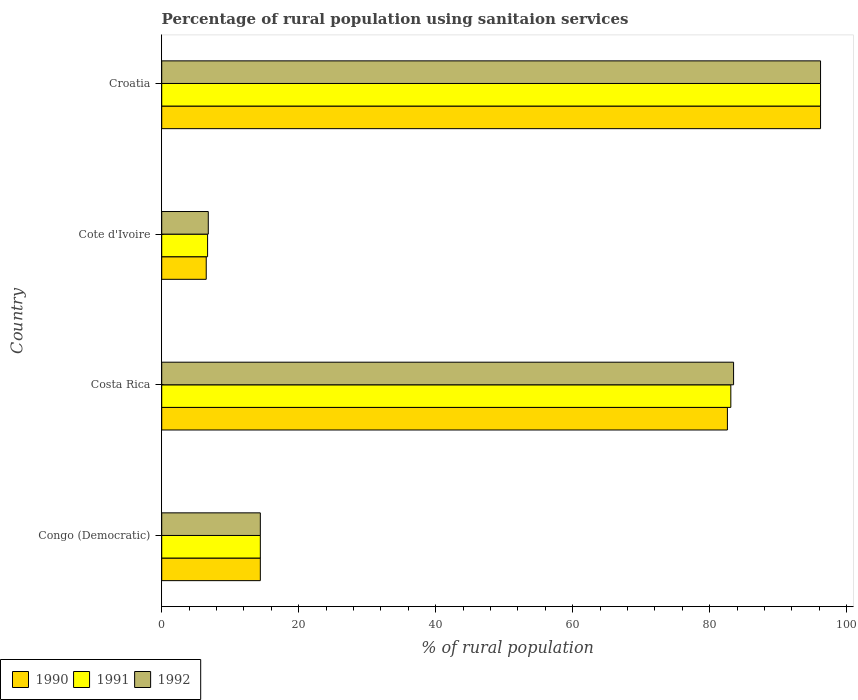Are the number of bars per tick equal to the number of legend labels?
Provide a succinct answer. Yes. How many bars are there on the 1st tick from the top?
Offer a very short reply. 3. In how many cases, is the number of bars for a given country not equal to the number of legend labels?
Provide a short and direct response. 0. What is the percentage of rural population using sanitaion services in 1992 in Congo (Democratic)?
Your answer should be compact. 14.4. Across all countries, what is the maximum percentage of rural population using sanitaion services in 1991?
Offer a terse response. 96.2. Across all countries, what is the minimum percentage of rural population using sanitaion services in 1991?
Offer a terse response. 6.7. In which country was the percentage of rural population using sanitaion services in 1991 maximum?
Your answer should be compact. Croatia. In which country was the percentage of rural population using sanitaion services in 1990 minimum?
Offer a very short reply. Cote d'Ivoire. What is the total percentage of rural population using sanitaion services in 1992 in the graph?
Your answer should be very brief. 200.9. What is the difference between the percentage of rural population using sanitaion services in 1990 in Costa Rica and that in Croatia?
Make the answer very short. -13.6. What is the difference between the percentage of rural population using sanitaion services in 1991 in Croatia and the percentage of rural population using sanitaion services in 1990 in Congo (Democratic)?
Make the answer very short. 81.8. What is the average percentage of rural population using sanitaion services in 1990 per country?
Ensure brevity in your answer.  49.92. What is the difference between the percentage of rural population using sanitaion services in 1990 and percentage of rural population using sanitaion services in 1992 in Congo (Democratic)?
Ensure brevity in your answer.  0. What is the ratio of the percentage of rural population using sanitaion services in 1991 in Congo (Democratic) to that in Croatia?
Your response must be concise. 0.15. What is the difference between the highest and the second highest percentage of rural population using sanitaion services in 1991?
Your answer should be very brief. 13.1. What is the difference between the highest and the lowest percentage of rural population using sanitaion services in 1992?
Your answer should be very brief. 89.4. In how many countries, is the percentage of rural population using sanitaion services in 1991 greater than the average percentage of rural population using sanitaion services in 1991 taken over all countries?
Provide a short and direct response. 2. Is the sum of the percentage of rural population using sanitaion services in 1990 in Congo (Democratic) and Cote d'Ivoire greater than the maximum percentage of rural population using sanitaion services in 1992 across all countries?
Offer a terse response. No. What does the 3rd bar from the bottom in Cote d'Ivoire represents?
Provide a short and direct response. 1992. How many bars are there?
Provide a succinct answer. 12. What is the difference between two consecutive major ticks on the X-axis?
Ensure brevity in your answer.  20. Where does the legend appear in the graph?
Your answer should be compact. Bottom left. How are the legend labels stacked?
Offer a very short reply. Horizontal. What is the title of the graph?
Keep it short and to the point. Percentage of rural population using sanitaion services. Does "2010" appear as one of the legend labels in the graph?
Your answer should be very brief. No. What is the label or title of the X-axis?
Your response must be concise. % of rural population. What is the % of rural population in 1991 in Congo (Democratic)?
Keep it short and to the point. 14.4. What is the % of rural population of 1990 in Costa Rica?
Make the answer very short. 82.6. What is the % of rural population of 1991 in Costa Rica?
Ensure brevity in your answer.  83.1. What is the % of rural population in 1992 in Costa Rica?
Make the answer very short. 83.5. What is the % of rural population in 1992 in Cote d'Ivoire?
Offer a terse response. 6.8. What is the % of rural population of 1990 in Croatia?
Offer a terse response. 96.2. What is the % of rural population of 1991 in Croatia?
Ensure brevity in your answer.  96.2. What is the % of rural population of 1992 in Croatia?
Offer a very short reply. 96.2. Across all countries, what is the maximum % of rural population in 1990?
Offer a very short reply. 96.2. Across all countries, what is the maximum % of rural population in 1991?
Provide a short and direct response. 96.2. Across all countries, what is the maximum % of rural population of 1992?
Ensure brevity in your answer.  96.2. Across all countries, what is the minimum % of rural population of 1992?
Provide a succinct answer. 6.8. What is the total % of rural population of 1990 in the graph?
Provide a short and direct response. 199.7. What is the total % of rural population in 1991 in the graph?
Ensure brevity in your answer.  200.4. What is the total % of rural population of 1992 in the graph?
Your answer should be compact. 200.9. What is the difference between the % of rural population in 1990 in Congo (Democratic) and that in Costa Rica?
Your answer should be very brief. -68.2. What is the difference between the % of rural population in 1991 in Congo (Democratic) and that in Costa Rica?
Your answer should be compact. -68.7. What is the difference between the % of rural population of 1992 in Congo (Democratic) and that in Costa Rica?
Offer a terse response. -69.1. What is the difference between the % of rural population in 1992 in Congo (Democratic) and that in Cote d'Ivoire?
Keep it short and to the point. 7.6. What is the difference between the % of rural population of 1990 in Congo (Democratic) and that in Croatia?
Your answer should be compact. -81.8. What is the difference between the % of rural population of 1991 in Congo (Democratic) and that in Croatia?
Your response must be concise. -81.8. What is the difference between the % of rural population in 1992 in Congo (Democratic) and that in Croatia?
Make the answer very short. -81.8. What is the difference between the % of rural population in 1990 in Costa Rica and that in Cote d'Ivoire?
Provide a succinct answer. 76.1. What is the difference between the % of rural population in 1991 in Costa Rica and that in Cote d'Ivoire?
Ensure brevity in your answer.  76.4. What is the difference between the % of rural population of 1992 in Costa Rica and that in Cote d'Ivoire?
Provide a short and direct response. 76.7. What is the difference between the % of rural population in 1990 in Costa Rica and that in Croatia?
Your answer should be very brief. -13.6. What is the difference between the % of rural population of 1991 in Costa Rica and that in Croatia?
Your response must be concise. -13.1. What is the difference between the % of rural population of 1992 in Costa Rica and that in Croatia?
Your answer should be compact. -12.7. What is the difference between the % of rural population of 1990 in Cote d'Ivoire and that in Croatia?
Ensure brevity in your answer.  -89.7. What is the difference between the % of rural population of 1991 in Cote d'Ivoire and that in Croatia?
Give a very brief answer. -89.5. What is the difference between the % of rural population of 1992 in Cote d'Ivoire and that in Croatia?
Your answer should be compact. -89.4. What is the difference between the % of rural population of 1990 in Congo (Democratic) and the % of rural population of 1991 in Costa Rica?
Make the answer very short. -68.7. What is the difference between the % of rural population in 1990 in Congo (Democratic) and the % of rural population in 1992 in Costa Rica?
Ensure brevity in your answer.  -69.1. What is the difference between the % of rural population in 1991 in Congo (Democratic) and the % of rural population in 1992 in Costa Rica?
Your response must be concise. -69.1. What is the difference between the % of rural population in 1990 in Congo (Democratic) and the % of rural population in 1991 in Croatia?
Your answer should be compact. -81.8. What is the difference between the % of rural population of 1990 in Congo (Democratic) and the % of rural population of 1992 in Croatia?
Ensure brevity in your answer.  -81.8. What is the difference between the % of rural population of 1991 in Congo (Democratic) and the % of rural population of 1992 in Croatia?
Keep it short and to the point. -81.8. What is the difference between the % of rural population in 1990 in Costa Rica and the % of rural population in 1991 in Cote d'Ivoire?
Make the answer very short. 75.9. What is the difference between the % of rural population of 1990 in Costa Rica and the % of rural population of 1992 in Cote d'Ivoire?
Provide a succinct answer. 75.8. What is the difference between the % of rural population of 1991 in Costa Rica and the % of rural population of 1992 in Cote d'Ivoire?
Provide a short and direct response. 76.3. What is the difference between the % of rural population in 1990 in Costa Rica and the % of rural population in 1992 in Croatia?
Offer a terse response. -13.6. What is the difference between the % of rural population in 1991 in Costa Rica and the % of rural population in 1992 in Croatia?
Provide a succinct answer. -13.1. What is the difference between the % of rural population of 1990 in Cote d'Ivoire and the % of rural population of 1991 in Croatia?
Keep it short and to the point. -89.7. What is the difference between the % of rural population in 1990 in Cote d'Ivoire and the % of rural population in 1992 in Croatia?
Ensure brevity in your answer.  -89.7. What is the difference between the % of rural population of 1991 in Cote d'Ivoire and the % of rural population of 1992 in Croatia?
Your answer should be compact. -89.5. What is the average % of rural population in 1990 per country?
Ensure brevity in your answer.  49.92. What is the average % of rural population of 1991 per country?
Offer a very short reply. 50.1. What is the average % of rural population in 1992 per country?
Make the answer very short. 50.23. What is the difference between the % of rural population in 1991 and % of rural population in 1992 in Congo (Democratic)?
Offer a terse response. 0. What is the difference between the % of rural population of 1991 and % of rural population of 1992 in Costa Rica?
Offer a very short reply. -0.4. What is the difference between the % of rural population of 1990 and % of rural population of 1992 in Cote d'Ivoire?
Provide a succinct answer. -0.3. What is the difference between the % of rural population in 1991 and % of rural population in 1992 in Cote d'Ivoire?
Offer a terse response. -0.1. What is the difference between the % of rural population in 1990 and % of rural population in 1991 in Croatia?
Provide a succinct answer. 0. What is the difference between the % of rural population in 1990 and % of rural population in 1992 in Croatia?
Provide a succinct answer. 0. What is the ratio of the % of rural population in 1990 in Congo (Democratic) to that in Costa Rica?
Make the answer very short. 0.17. What is the ratio of the % of rural population of 1991 in Congo (Democratic) to that in Costa Rica?
Offer a terse response. 0.17. What is the ratio of the % of rural population of 1992 in Congo (Democratic) to that in Costa Rica?
Make the answer very short. 0.17. What is the ratio of the % of rural population in 1990 in Congo (Democratic) to that in Cote d'Ivoire?
Provide a succinct answer. 2.22. What is the ratio of the % of rural population in 1991 in Congo (Democratic) to that in Cote d'Ivoire?
Keep it short and to the point. 2.15. What is the ratio of the % of rural population of 1992 in Congo (Democratic) to that in Cote d'Ivoire?
Ensure brevity in your answer.  2.12. What is the ratio of the % of rural population in 1990 in Congo (Democratic) to that in Croatia?
Provide a succinct answer. 0.15. What is the ratio of the % of rural population in 1991 in Congo (Democratic) to that in Croatia?
Your answer should be compact. 0.15. What is the ratio of the % of rural population of 1992 in Congo (Democratic) to that in Croatia?
Your answer should be compact. 0.15. What is the ratio of the % of rural population of 1990 in Costa Rica to that in Cote d'Ivoire?
Offer a very short reply. 12.71. What is the ratio of the % of rural population in 1991 in Costa Rica to that in Cote d'Ivoire?
Your answer should be very brief. 12.4. What is the ratio of the % of rural population in 1992 in Costa Rica to that in Cote d'Ivoire?
Make the answer very short. 12.28. What is the ratio of the % of rural population of 1990 in Costa Rica to that in Croatia?
Your response must be concise. 0.86. What is the ratio of the % of rural population of 1991 in Costa Rica to that in Croatia?
Make the answer very short. 0.86. What is the ratio of the % of rural population in 1992 in Costa Rica to that in Croatia?
Provide a short and direct response. 0.87. What is the ratio of the % of rural population of 1990 in Cote d'Ivoire to that in Croatia?
Ensure brevity in your answer.  0.07. What is the ratio of the % of rural population of 1991 in Cote d'Ivoire to that in Croatia?
Offer a very short reply. 0.07. What is the ratio of the % of rural population in 1992 in Cote d'Ivoire to that in Croatia?
Make the answer very short. 0.07. What is the difference between the highest and the lowest % of rural population in 1990?
Provide a short and direct response. 89.7. What is the difference between the highest and the lowest % of rural population of 1991?
Provide a succinct answer. 89.5. What is the difference between the highest and the lowest % of rural population in 1992?
Make the answer very short. 89.4. 